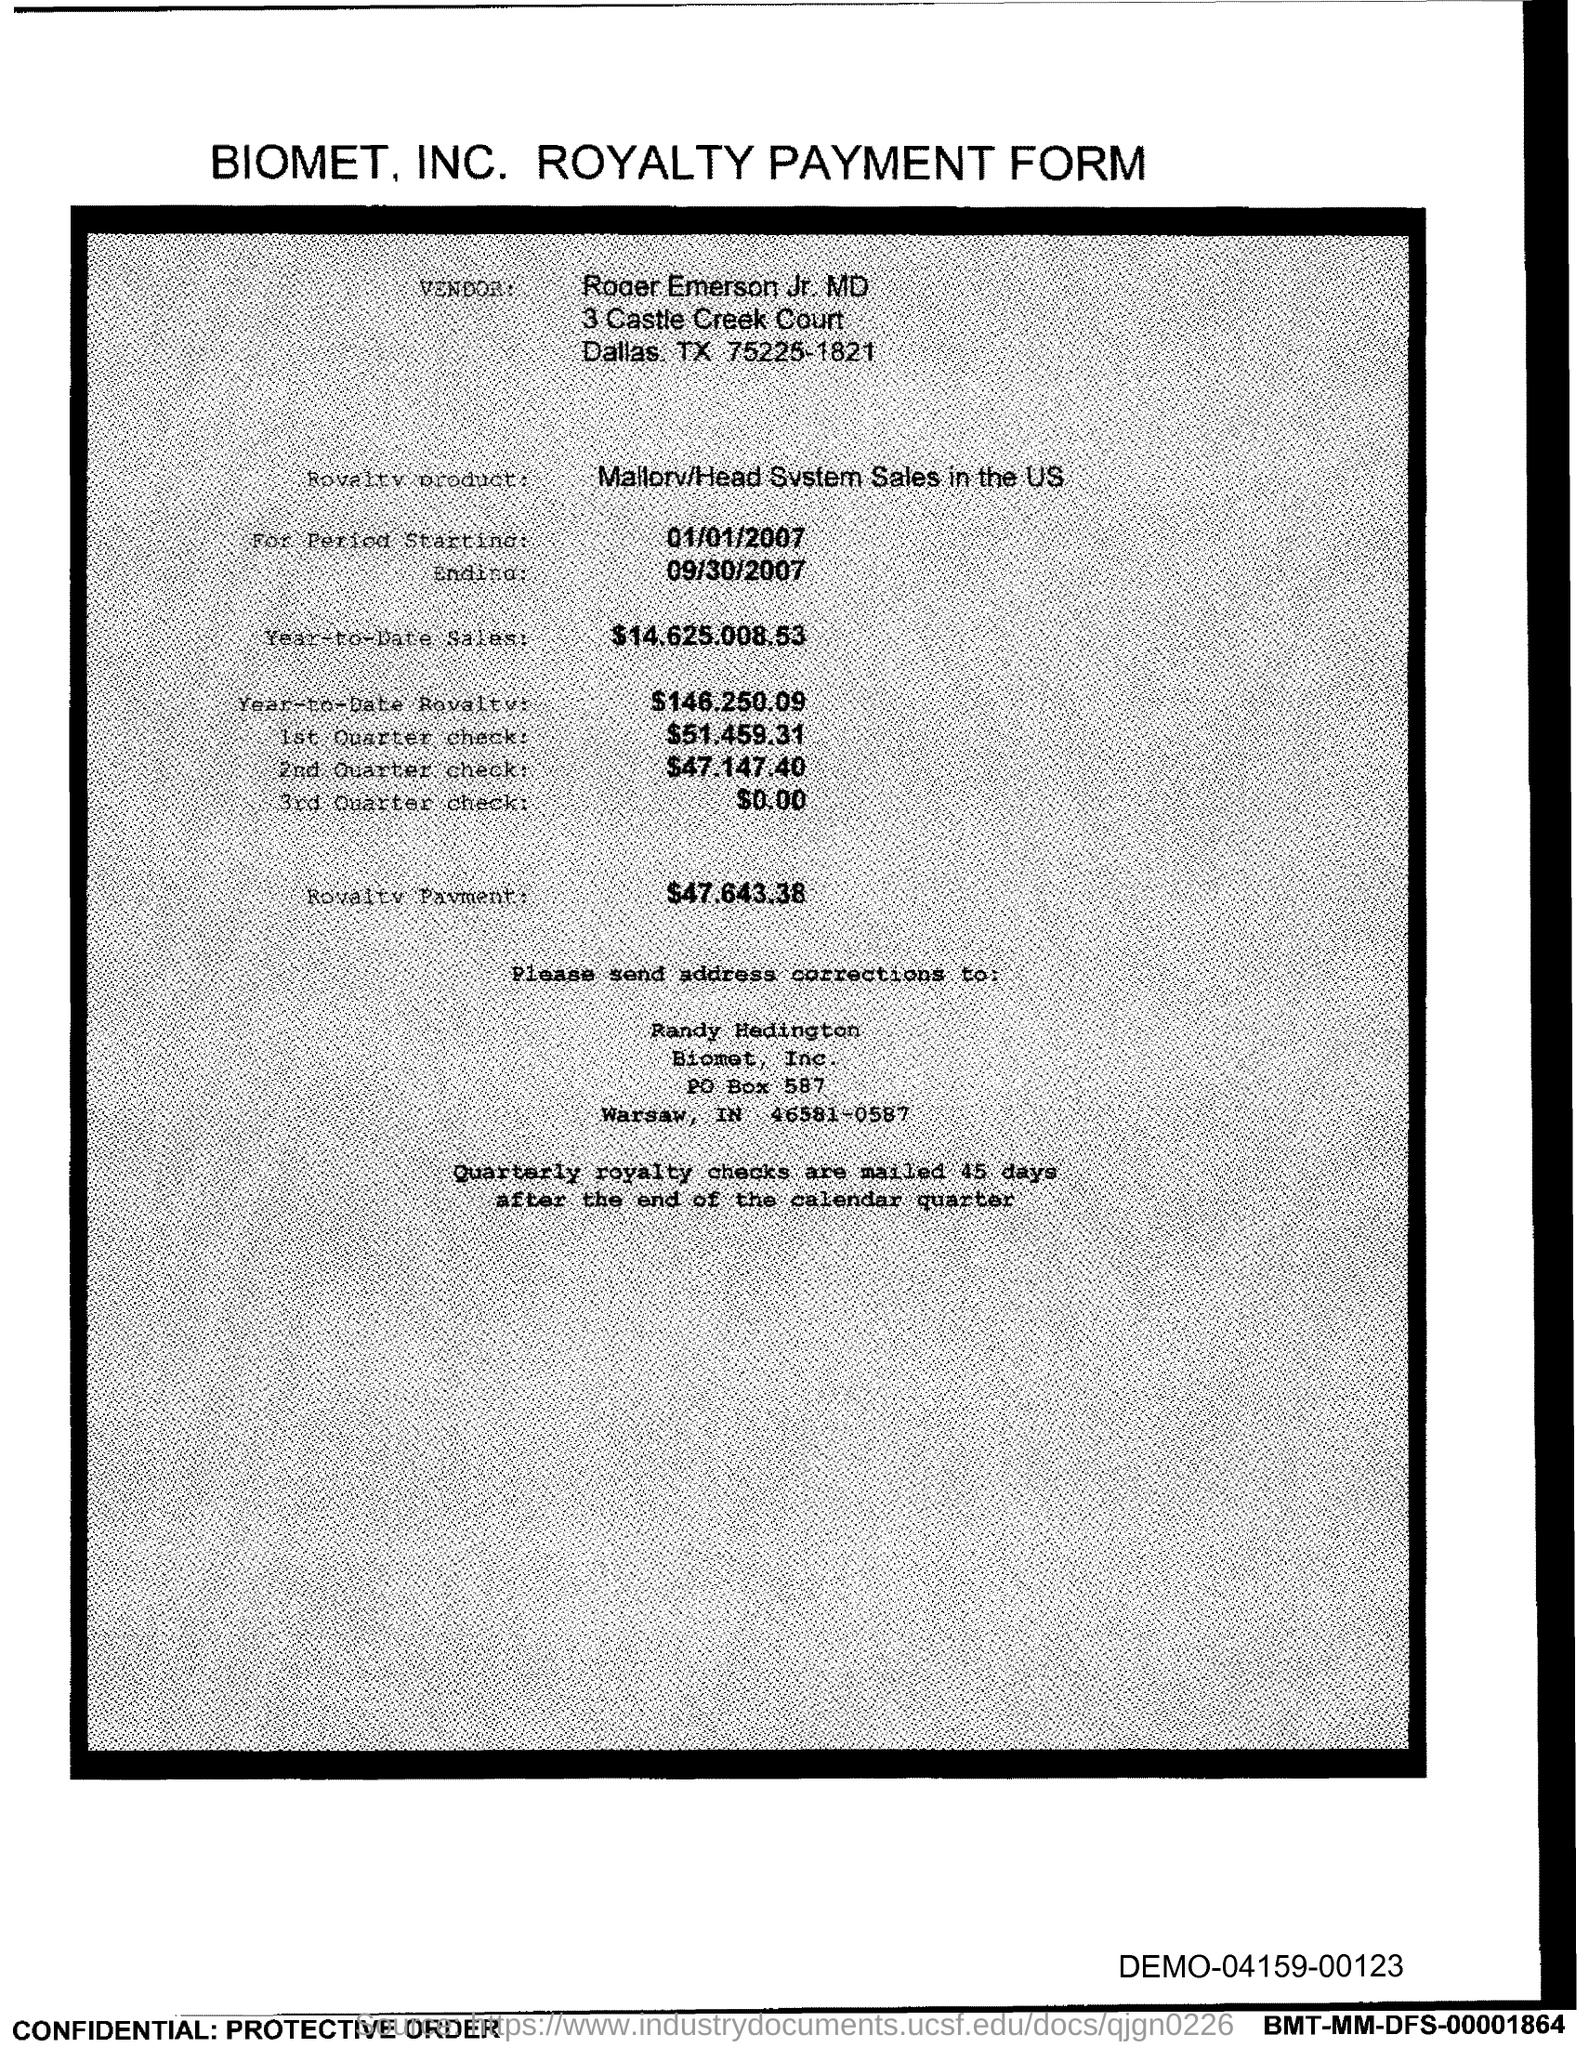What are the amounts listed for each quarterly check? The amounts for each quarterly check are as follows: the 1st Quarter check is $51,459.31, the 2nd Quarter check is $47,147.40, and no amount is listed for the 3rd Quarter check. 